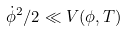<formula> <loc_0><loc_0><loc_500><loc_500>\dot { \phi } ^ { 2 } / 2 \ll V ( \phi , T )</formula> 